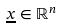<formula> <loc_0><loc_0><loc_500><loc_500>\underline { x } \in \mathbb { R } ^ { n }</formula> 